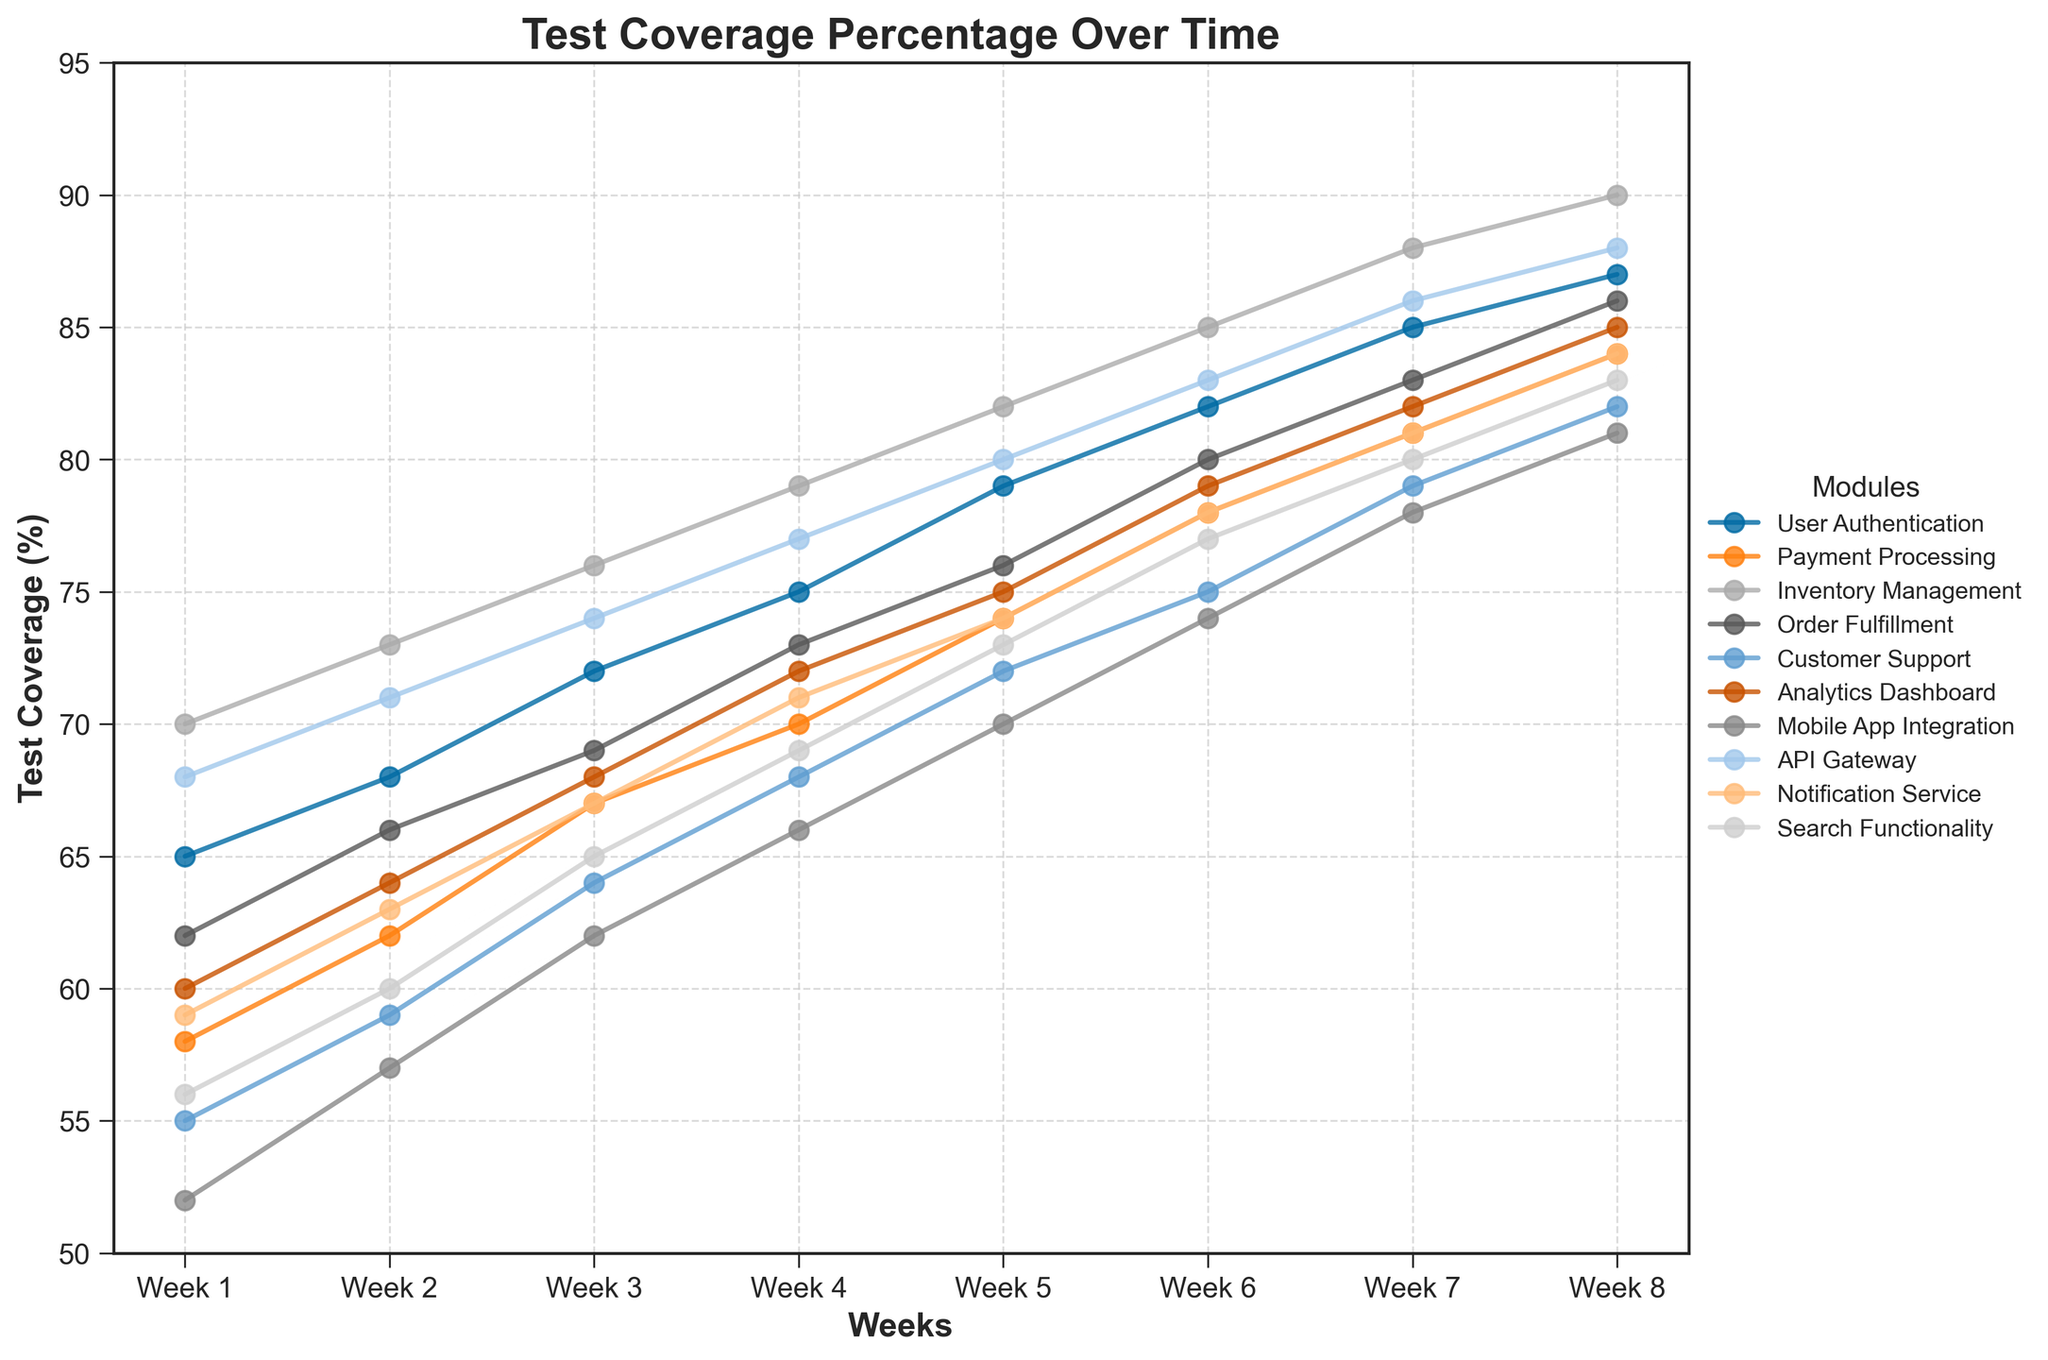Which module has the highest test coverage by Week 8? In Week 8, find the module with the highest value of test coverage. From the figure, it is Inventory Management with 90%.
Answer: Inventory Management Which two modules have the closest test coverage in Week 5? In Week 5, compare the test coverage percentages of all modules and identify the two with the smallest difference. Customer Support has 72% and Search Functionality has 73%, making their difference the smallest.
Answer: Customer Support and Search Functionality What is the average test coverage for the API Gateway from Week 1 to Week 8? Sum up the coverage percentages for the API Gateway across all weeks (68+71+74+77+80+83+86+88) and divide by the number of weeks (8). The sum is 627, and the average is 627/8, which is approximately 78.4%.
Answer: Approximately 78.4% Which module shows the greatest improvement in test coverage from Week 1 to Week 8? Calculate the difference in test coverage between Week 1 and Week 8 for each module. Inventory Management shows the greatest improvement, going from 70% to 90%, which is a 20% increase.
Answer: Inventory Management Between Week 2 and Week 4, which module had the largest single-week percentage increase in test coverage? Check the difference in test coverage week by week between Week 2 and Week 4 for all modules. User Authentication had a 3% increase from Week 2 to Week 3 and another 3% from Week 3 to Week 4, which is the highest single-week percentage increase.
Answer: User Authentication Which two modules have an equal test coverage percentage by the end of Week 6? Look at the Week 6 data and check for matching test coverage values. Payment Processing and Notification Service both have 78% test coverage.
Answer: Payment Processing and Notification Service How much did the test coverage for Mobile App Integration increase from Week 1 to Week 7? Subtract the Week 1 test coverage for Mobile App Integration (52%) from the Week 7 test coverage (78%) to find the increase. The increase is 78% - 52% = 26%.
Answer: 26% Which module had the smallest increase in test coverage over the first three weeks? Compare the differences in test coverage from Week 1 to Week 3 for each module. Mobile App Integration increased by (62% - 52%) 10%, which is the smallest increase.
Answer: Mobile App Integration From Week 4 to Week 5, which module experienced a decrease or no change in test coverage? Compare the test coverage percentages from Week 4 to Week 5 for all modules. All modules experienced an increase; thus, none exhibited a decrease or no change.
Answer: None 